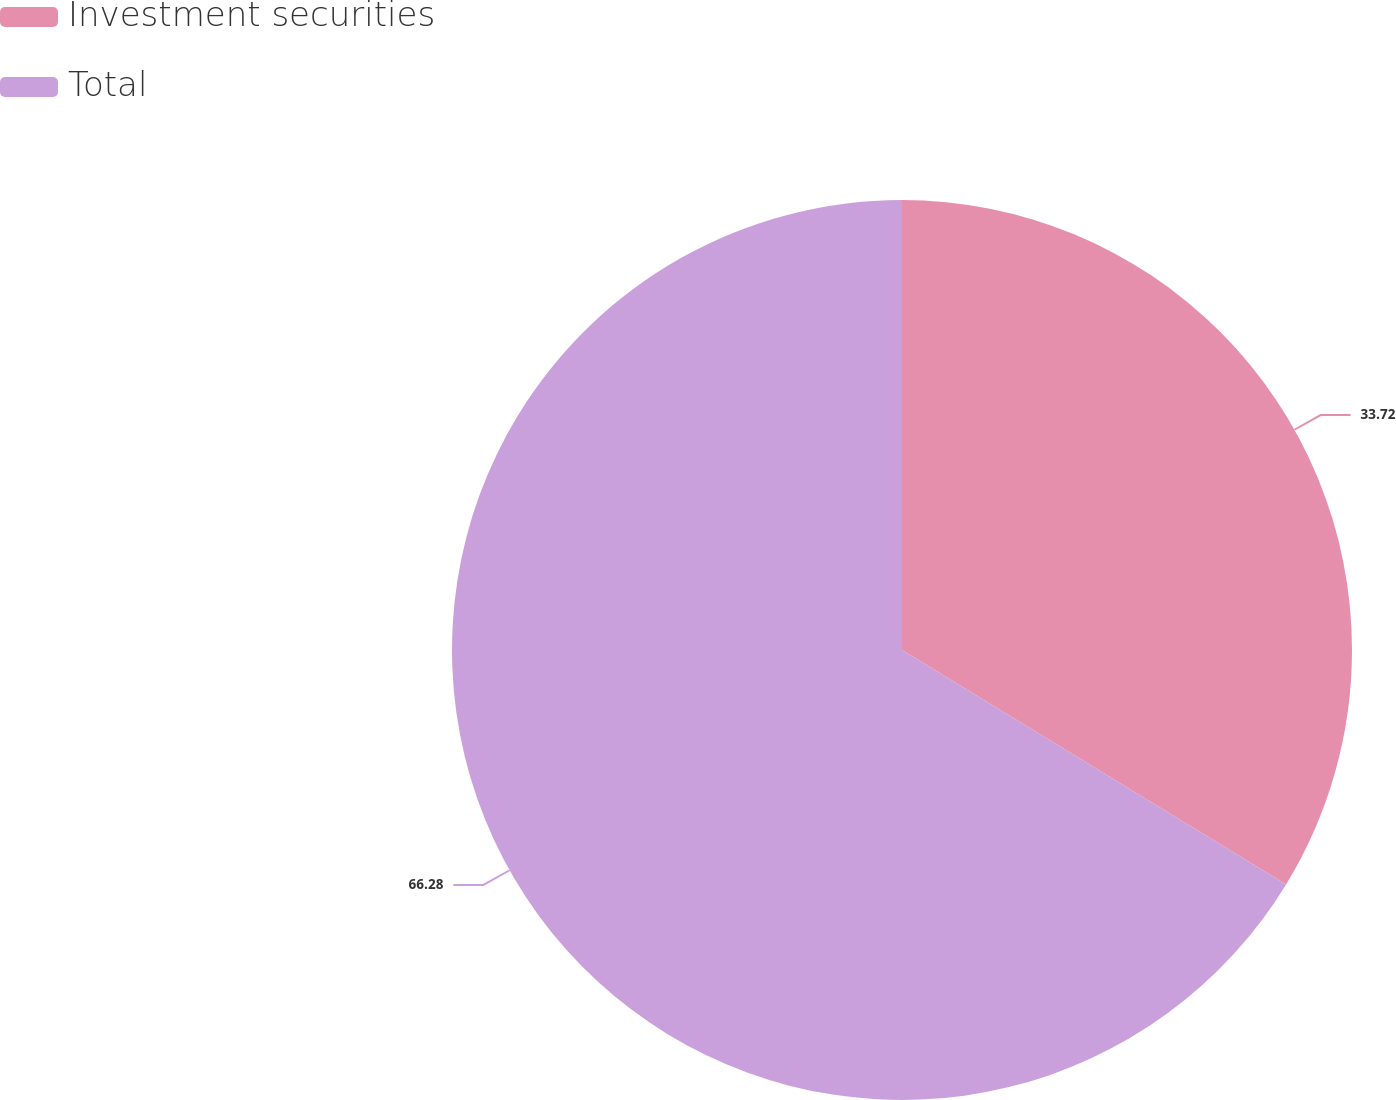<chart> <loc_0><loc_0><loc_500><loc_500><pie_chart><fcel>Investment securities<fcel>Total<nl><fcel>33.72%<fcel>66.28%<nl></chart> 